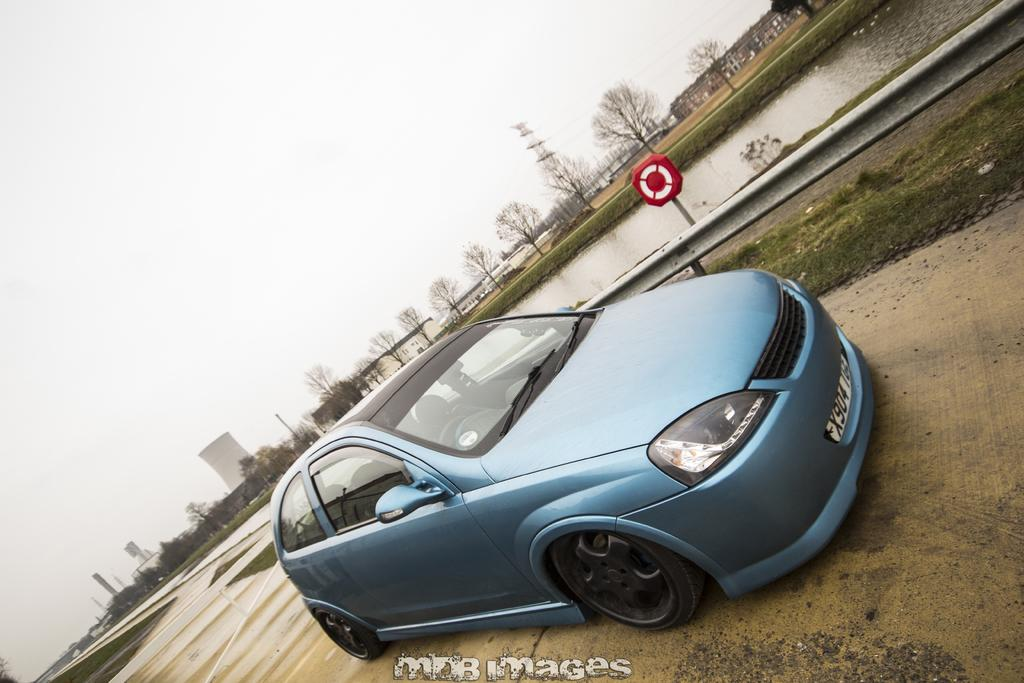What is the main subject of the image? There is a car on the road in the image. Can you describe any specific features of the car? The car is on the road, but there is no specific information about its features. What type of natural environment can be seen in the image? There is grass, water, and trees visible in the image. What type of man-made structures are present in the image? There are buildings in the image. What is visible in the background of the image? The sky is visible in the background of the image. Can you tell me how many pears are on the zebra in the image? There are no pears or zebras present in the image. What is the name of the son of the person who took the picture? There is no information about the person who took the picture or their son in the provided facts. 